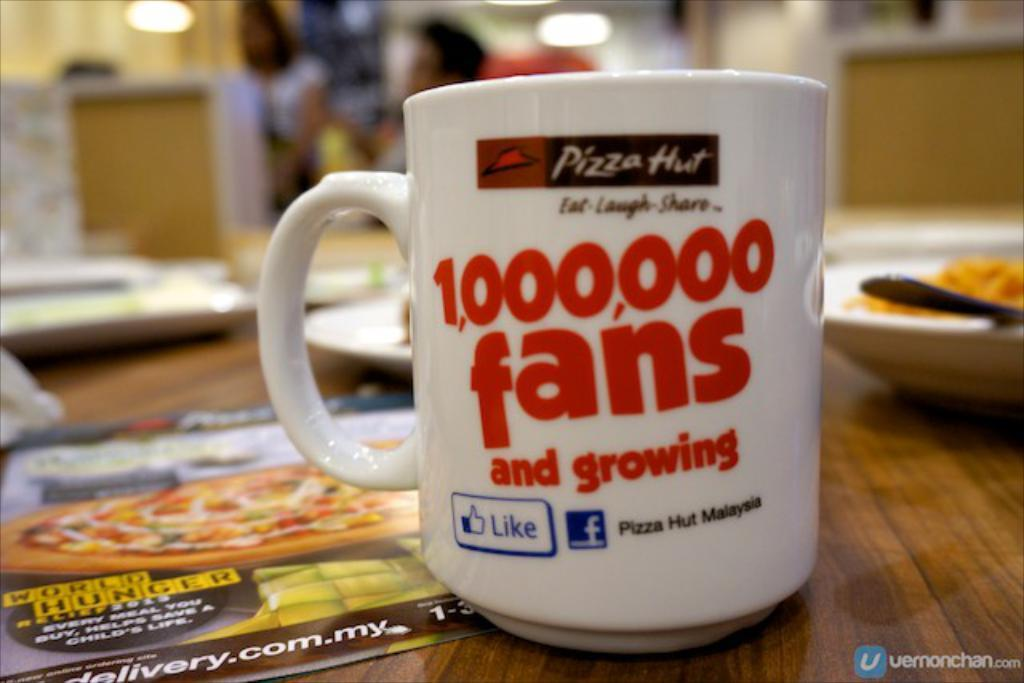<image>
Create a compact narrative representing the image presented. a cup with pizza hut written on it 